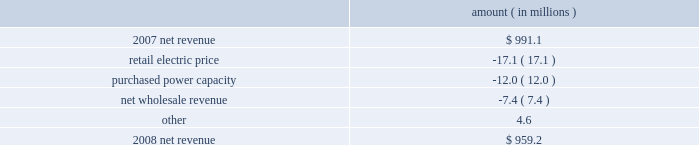Entergy louisiana , llc management's financial discussion and analysis net revenue 2008 compared to 2007 net revenue consists of operating revenues net of : 1 ) fuel , fuel-related expenses , and gas purchased for resale , 2 ) purchased power expenses , and 3 ) other regulatory charges .
Following is an analysis of the change in net revenue comparing 2008 to 2007 .
Amount ( in millions ) .
The retail electric price variance is primarily due to the cessation of the interim storm recovery through the formula rate plan upon the act 55 financing of storm costs and a credit passed on to customers as a result of the act 55 storm cost financing , partially offset by increases in the formula rate plan effective october 2007 .
Refer to "hurricane rita and hurricane katrina" and "state and local rate regulation" below for a discussion of the interim recovery of storm costs , the act 55 storm cost financing , and the formula rate plan filing .
The purchased power capacity variance is due to the amortization of deferred capacity costs effective september 2007 as a result of the formula rate plan filing in may 2007 .
Purchased power capacity costs are offset in base revenues due to a base rate increase implemented to recover incremental deferred and ongoing purchased power capacity charges .
See "state and local rate regulation" below for a discussion of the formula rate plan filing .
The net wholesale revenue variance is primarily due to provisions recorded for potential rate refunds related to the treatment of interruptible load in pricing entergy system affiliate sales .
Gross operating revenue and , fuel and purchased power expenses gross operating revenues increased primarily due to an increase of $ 364.7 million in fuel cost recovery revenues due to higher fuel rates offset by decreased usage .
The increase was partially offset by a decrease of $ 56.8 million in gross wholesale revenue due to a decrease in system agreement rough production cost equalization credits .
Fuel and purchased power expenses increased primarily due to increases in the average market prices of natural gas and purchased power , partially offset by a decrease in the recovery from customers of deferred fuel costs. .
What is the growth rate in net revenue in 2008? 
Computations: ((959.2 - 991.1) / 991.1)
Answer: -0.03219. 